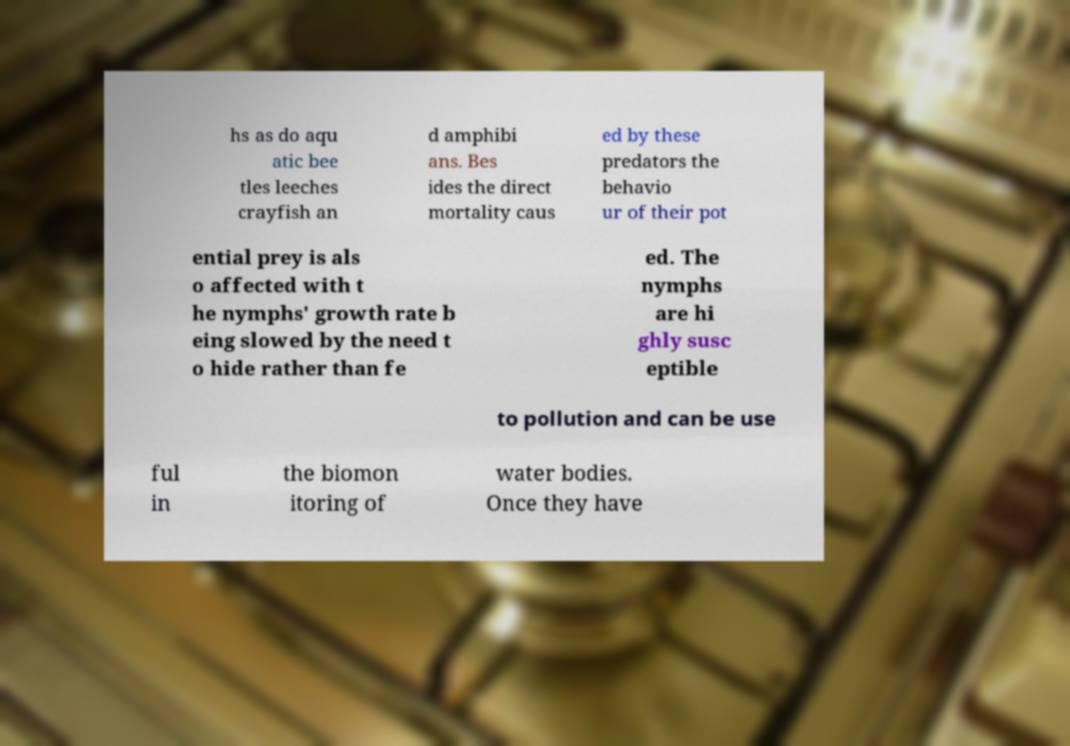Please identify and transcribe the text found in this image. hs as do aqu atic bee tles leeches crayfish an d amphibi ans. Bes ides the direct mortality caus ed by these predators the behavio ur of their pot ential prey is als o affected with t he nymphs' growth rate b eing slowed by the need t o hide rather than fe ed. The nymphs are hi ghly susc eptible to pollution and can be use ful in the biomon itoring of water bodies. Once they have 